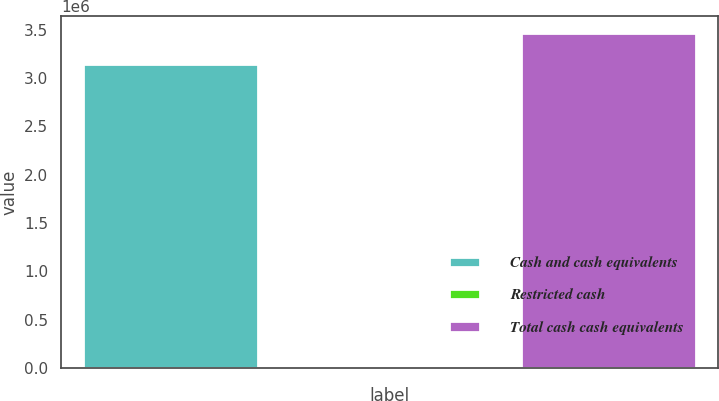Convert chart to OTSL. <chart><loc_0><loc_0><loc_500><loc_500><bar_chart><fcel>Cash and cash equivalents<fcel>Restricted cash<fcel>Total cash cash equivalents<nl><fcel>3.14865e+06<fcel>843<fcel>3.46352e+06<nl></chart> 